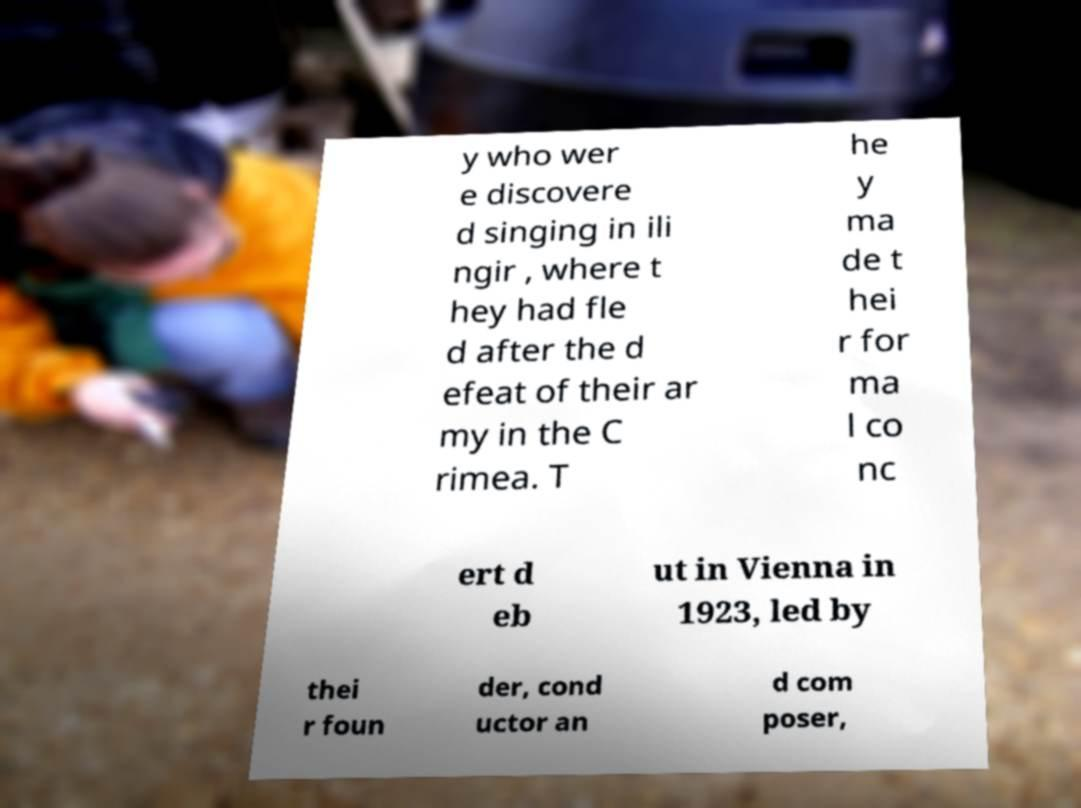I need the written content from this picture converted into text. Can you do that? y who wer e discovere d singing in ili ngir , where t hey had fle d after the d efeat of their ar my in the C rimea. T he y ma de t hei r for ma l co nc ert d eb ut in Vienna in 1923, led by thei r foun der, cond uctor an d com poser, 